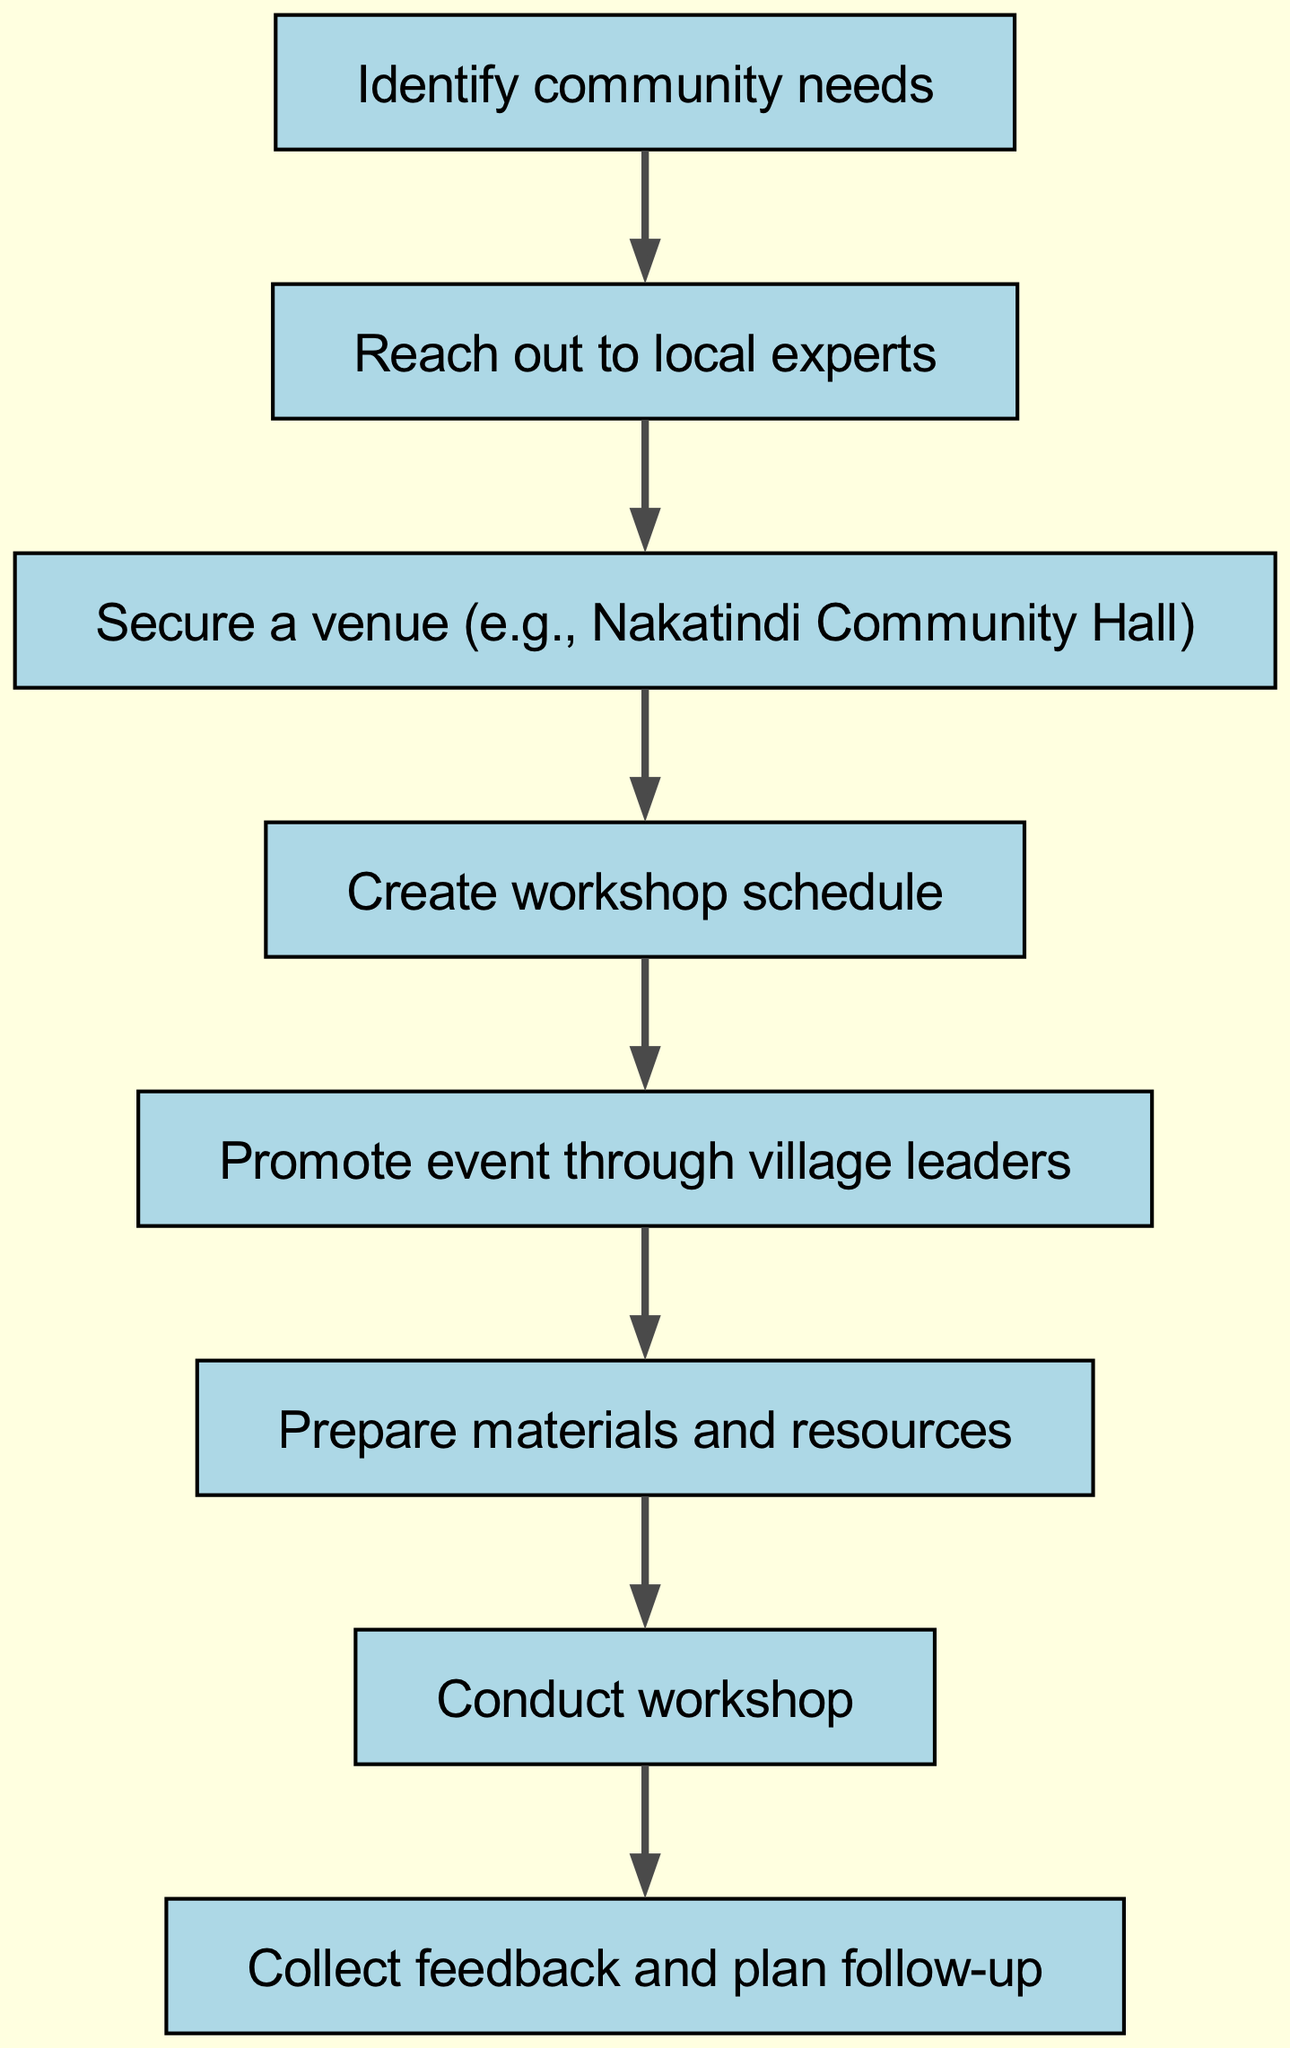What is the first step in the workshop organization process? The first node in the diagram shows "Identify community needs" as the initial step before any other actions are taken.
Answer: Identify community needs How many steps are involved in organizing the workshop? To determine the number of steps, we count the nodes in the diagram, which total eight distinct actions from start to finish.
Answer: 8 What is the last action taken in the process? The final node in the flow chart states "Collect feedback and plan follow-up", indicating this is the last action after conducting the workshop.
Answer: Collect feedback and plan follow-up Which action follows securing a venue? In the flow of the diagram, after "Secure a venue (e.g., Nakatindi Community Hall)", the next action is "Create workshop schedule".
Answer: Create workshop schedule Who should be contacted for event promotion? The diagram specifies that the action "Promote event through village leaders" indicates that village leaders should be contacted for promotion.
Answer: Village leaders What step comes after preparing materials and resources? The logical flow shows that after the preparation of materials, the next step is to "Conduct workshop", indicating the transition to the actual event.
Answer: Conduct workshop How does reaching out to local experts contribute to the process? Reaching out to local experts is crucial as it directly follows identifying community needs, ensuring that the right skills will be shared during the workshop. This action connects to securing relevant knowledge needed for the event.
Answer: It ensures relevant skills are shared Is creating a workshop schedule independent of reaching out to local experts? No, it is not independent; the diagram clearly shows that one action must follow the other—specifically, creating a workshop schedule cannot occur until local experts have been contacted for input.
Answer: No 